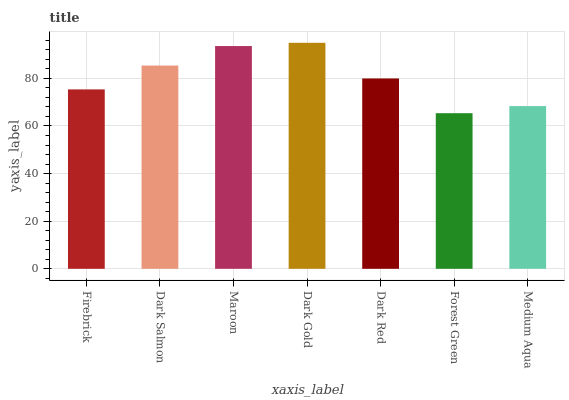Is Dark Salmon the minimum?
Answer yes or no. No. Is Dark Salmon the maximum?
Answer yes or no. No. Is Dark Salmon greater than Firebrick?
Answer yes or no. Yes. Is Firebrick less than Dark Salmon?
Answer yes or no. Yes. Is Firebrick greater than Dark Salmon?
Answer yes or no. No. Is Dark Salmon less than Firebrick?
Answer yes or no. No. Is Dark Red the high median?
Answer yes or no. Yes. Is Dark Red the low median?
Answer yes or no. Yes. Is Dark Gold the high median?
Answer yes or no. No. Is Medium Aqua the low median?
Answer yes or no. No. 